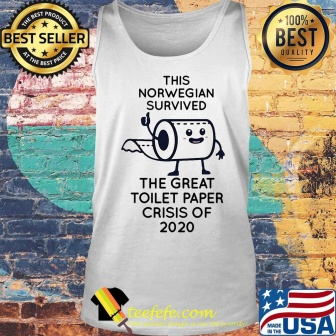What's the idea behind the design on this tank top? The tank top's design whimsically pays homage to the unusual and memorable period at the start of the COVID-19 pandemic when toilet paper became an unexpectedly valuable commodity. It conveys a lighthearted take on human behavior during crises, using a cartoon roll of toilet paper as a symbol of resilience and survival, alongside a proud declaration of overcoming the shortage. Why would someone choose to wear this kind of tank top? Someone might choose to wear this tank top as a humorous conversation starter, to share in the collective memory of an extraordinary time, or to display a touch of irony about the situation. It serves as a playful reminder of the shared human experiences and coping strategies during the pandemic lockdowns. 